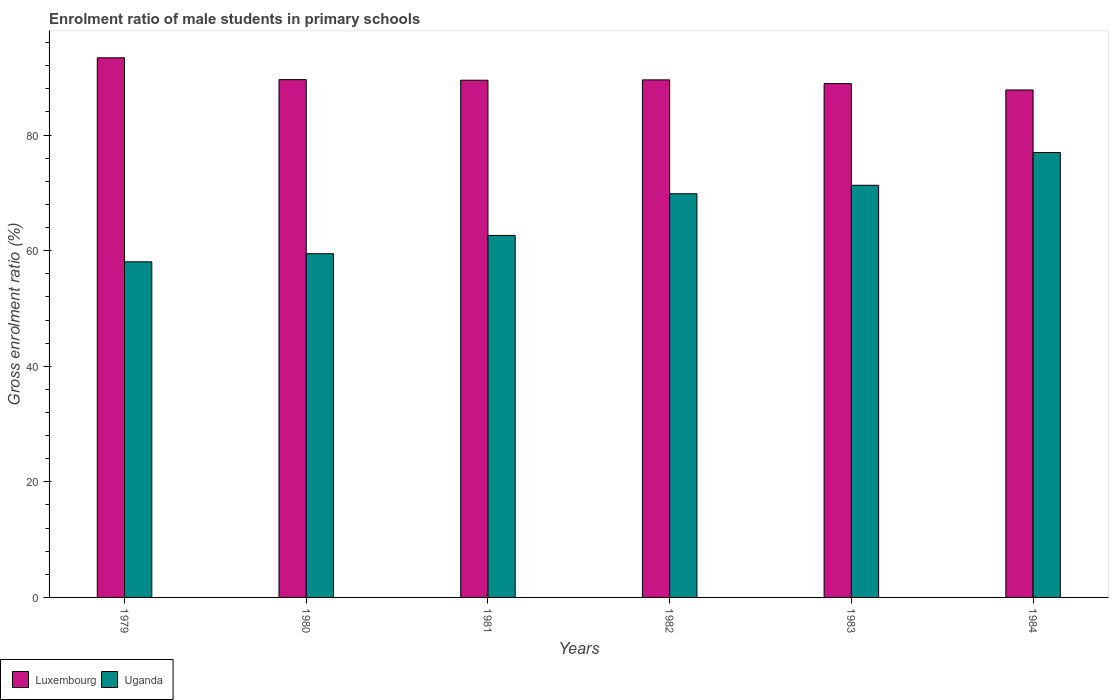How many different coloured bars are there?
Provide a short and direct response. 2. Are the number of bars per tick equal to the number of legend labels?
Offer a very short reply. Yes. How many bars are there on the 6th tick from the right?
Keep it short and to the point. 2. What is the enrolment ratio of male students in primary schools in Uganda in 1980?
Give a very brief answer. 59.48. Across all years, what is the maximum enrolment ratio of male students in primary schools in Luxembourg?
Ensure brevity in your answer.  93.38. Across all years, what is the minimum enrolment ratio of male students in primary schools in Uganda?
Your answer should be very brief. 58.07. In which year was the enrolment ratio of male students in primary schools in Uganda minimum?
Make the answer very short. 1979. What is the total enrolment ratio of male students in primary schools in Uganda in the graph?
Make the answer very short. 398.34. What is the difference between the enrolment ratio of male students in primary schools in Uganda in 1982 and that in 1983?
Ensure brevity in your answer.  -1.47. What is the difference between the enrolment ratio of male students in primary schools in Luxembourg in 1982 and the enrolment ratio of male students in primary schools in Uganda in 1984?
Provide a short and direct response. 12.58. What is the average enrolment ratio of male students in primary schools in Luxembourg per year?
Provide a short and direct response. 89.79. In the year 1980, what is the difference between the enrolment ratio of male students in primary schools in Luxembourg and enrolment ratio of male students in primary schools in Uganda?
Provide a short and direct response. 30.12. What is the ratio of the enrolment ratio of male students in primary schools in Luxembourg in 1980 to that in 1981?
Give a very brief answer. 1. What is the difference between the highest and the second highest enrolment ratio of male students in primary schools in Uganda?
Give a very brief answer. 5.66. What is the difference between the highest and the lowest enrolment ratio of male students in primary schools in Uganda?
Offer a terse response. 18.91. What does the 1st bar from the left in 1981 represents?
Make the answer very short. Luxembourg. What does the 1st bar from the right in 1981 represents?
Make the answer very short. Uganda. Are all the bars in the graph horizontal?
Ensure brevity in your answer.  No. Does the graph contain any zero values?
Ensure brevity in your answer.  No. Where does the legend appear in the graph?
Give a very brief answer. Bottom left. How are the legend labels stacked?
Offer a terse response. Horizontal. What is the title of the graph?
Provide a succinct answer. Enrolment ratio of male students in primary schools. Does "Angola" appear as one of the legend labels in the graph?
Provide a short and direct response. No. What is the Gross enrolment ratio (%) of Luxembourg in 1979?
Make the answer very short. 93.38. What is the Gross enrolment ratio (%) of Uganda in 1979?
Offer a terse response. 58.07. What is the Gross enrolment ratio (%) in Luxembourg in 1980?
Offer a terse response. 89.6. What is the Gross enrolment ratio (%) in Uganda in 1980?
Provide a succinct answer. 59.48. What is the Gross enrolment ratio (%) of Luxembourg in 1981?
Give a very brief answer. 89.5. What is the Gross enrolment ratio (%) of Uganda in 1981?
Offer a terse response. 62.64. What is the Gross enrolment ratio (%) of Luxembourg in 1982?
Provide a short and direct response. 89.56. What is the Gross enrolment ratio (%) of Uganda in 1982?
Make the answer very short. 69.85. What is the Gross enrolment ratio (%) in Luxembourg in 1983?
Make the answer very short. 88.91. What is the Gross enrolment ratio (%) of Uganda in 1983?
Provide a short and direct response. 71.32. What is the Gross enrolment ratio (%) in Luxembourg in 1984?
Provide a succinct answer. 87.81. What is the Gross enrolment ratio (%) of Uganda in 1984?
Provide a succinct answer. 76.98. Across all years, what is the maximum Gross enrolment ratio (%) in Luxembourg?
Your answer should be very brief. 93.38. Across all years, what is the maximum Gross enrolment ratio (%) of Uganda?
Provide a short and direct response. 76.98. Across all years, what is the minimum Gross enrolment ratio (%) of Luxembourg?
Provide a short and direct response. 87.81. Across all years, what is the minimum Gross enrolment ratio (%) of Uganda?
Your answer should be compact. 58.07. What is the total Gross enrolment ratio (%) in Luxembourg in the graph?
Give a very brief answer. 538.75. What is the total Gross enrolment ratio (%) in Uganda in the graph?
Offer a very short reply. 398.34. What is the difference between the Gross enrolment ratio (%) in Luxembourg in 1979 and that in 1980?
Offer a very short reply. 3.78. What is the difference between the Gross enrolment ratio (%) of Uganda in 1979 and that in 1980?
Offer a terse response. -1.4. What is the difference between the Gross enrolment ratio (%) of Luxembourg in 1979 and that in 1981?
Give a very brief answer. 3.88. What is the difference between the Gross enrolment ratio (%) of Uganda in 1979 and that in 1981?
Make the answer very short. -4.57. What is the difference between the Gross enrolment ratio (%) of Luxembourg in 1979 and that in 1982?
Your answer should be very brief. 3.82. What is the difference between the Gross enrolment ratio (%) of Uganda in 1979 and that in 1982?
Your answer should be very brief. -11.78. What is the difference between the Gross enrolment ratio (%) of Luxembourg in 1979 and that in 1983?
Give a very brief answer. 4.46. What is the difference between the Gross enrolment ratio (%) of Uganda in 1979 and that in 1983?
Your answer should be compact. -13.25. What is the difference between the Gross enrolment ratio (%) of Luxembourg in 1979 and that in 1984?
Your answer should be compact. 5.56. What is the difference between the Gross enrolment ratio (%) of Uganda in 1979 and that in 1984?
Your answer should be very brief. -18.91. What is the difference between the Gross enrolment ratio (%) in Luxembourg in 1980 and that in 1981?
Make the answer very short. 0.1. What is the difference between the Gross enrolment ratio (%) of Uganda in 1980 and that in 1981?
Make the answer very short. -3.16. What is the difference between the Gross enrolment ratio (%) of Luxembourg in 1980 and that in 1982?
Your response must be concise. 0.04. What is the difference between the Gross enrolment ratio (%) of Uganda in 1980 and that in 1982?
Your response must be concise. -10.38. What is the difference between the Gross enrolment ratio (%) of Luxembourg in 1980 and that in 1983?
Make the answer very short. 0.69. What is the difference between the Gross enrolment ratio (%) in Uganda in 1980 and that in 1983?
Keep it short and to the point. -11.84. What is the difference between the Gross enrolment ratio (%) of Luxembourg in 1980 and that in 1984?
Provide a short and direct response. 1.79. What is the difference between the Gross enrolment ratio (%) of Uganda in 1980 and that in 1984?
Your response must be concise. -17.51. What is the difference between the Gross enrolment ratio (%) of Luxembourg in 1981 and that in 1982?
Your response must be concise. -0.06. What is the difference between the Gross enrolment ratio (%) of Uganda in 1981 and that in 1982?
Ensure brevity in your answer.  -7.21. What is the difference between the Gross enrolment ratio (%) in Luxembourg in 1981 and that in 1983?
Your response must be concise. 0.59. What is the difference between the Gross enrolment ratio (%) of Uganda in 1981 and that in 1983?
Offer a terse response. -8.68. What is the difference between the Gross enrolment ratio (%) in Luxembourg in 1981 and that in 1984?
Provide a short and direct response. 1.69. What is the difference between the Gross enrolment ratio (%) of Uganda in 1981 and that in 1984?
Your answer should be compact. -14.34. What is the difference between the Gross enrolment ratio (%) of Luxembourg in 1982 and that in 1983?
Provide a succinct answer. 0.65. What is the difference between the Gross enrolment ratio (%) in Uganda in 1982 and that in 1983?
Offer a terse response. -1.47. What is the difference between the Gross enrolment ratio (%) in Luxembourg in 1982 and that in 1984?
Give a very brief answer. 1.75. What is the difference between the Gross enrolment ratio (%) of Uganda in 1982 and that in 1984?
Your response must be concise. -7.13. What is the difference between the Gross enrolment ratio (%) of Luxembourg in 1983 and that in 1984?
Keep it short and to the point. 1.1. What is the difference between the Gross enrolment ratio (%) of Uganda in 1983 and that in 1984?
Your answer should be compact. -5.66. What is the difference between the Gross enrolment ratio (%) in Luxembourg in 1979 and the Gross enrolment ratio (%) in Uganda in 1980?
Give a very brief answer. 33.9. What is the difference between the Gross enrolment ratio (%) of Luxembourg in 1979 and the Gross enrolment ratio (%) of Uganda in 1981?
Keep it short and to the point. 30.74. What is the difference between the Gross enrolment ratio (%) of Luxembourg in 1979 and the Gross enrolment ratio (%) of Uganda in 1982?
Offer a very short reply. 23.52. What is the difference between the Gross enrolment ratio (%) in Luxembourg in 1979 and the Gross enrolment ratio (%) in Uganda in 1983?
Keep it short and to the point. 22.06. What is the difference between the Gross enrolment ratio (%) in Luxembourg in 1979 and the Gross enrolment ratio (%) in Uganda in 1984?
Your response must be concise. 16.39. What is the difference between the Gross enrolment ratio (%) in Luxembourg in 1980 and the Gross enrolment ratio (%) in Uganda in 1981?
Offer a very short reply. 26.96. What is the difference between the Gross enrolment ratio (%) in Luxembourg in 1980 and the Gross enrolment ratio (%) in Uganda in 1982?
Make the answer very short. 19.75. What is the difference between the Gross enrolment ratio (%) in Luxembourg in 1980 and the Gross enrolment ratio (%) in Uganda in 1983?
Your response must be concise. 18.28. What is the difference between the Gross enrolment ratio (%) of Luxembourg in 1980 and the Gross enrolment ratio (%) of Uganda in 1984?
Make the answer very short. 12.62. What is the difference between the Gross enrolment ratio (%) of Luxembourg in 1981 and the Gross enrolment ratio (%) of Uganda in 1982?
Your response must be concise. 19.65. What is the difference between the Gross enrolment ratio (%) of Luxembourg in 1981 and the Gross enrolment ratio (%) of Uganda in 1983?
Provide a short and direct response. 18.18. What is the difference between the Gross enrolment ratio (%) in Luxembourg in 1981 and the Gross enrolment ratio (%) in Uganda in 1984?
Make the answer very short. 12.52. What is the difference between the Gross enrolment ratio (%) in Luxembourg in 1982 and the Gross enrolment ratio (%) in Uganda in 1983?
Offer a very short reply. 18.24. What is the difference between the Gross enrolment ratio (%) in Luxembourg in 1982 and the Gross enrolment ratio (%) in Uganda in 1984?
Offer a very short reply. 12.58. What is the difference between the Gross enrolment ratio (%) of Luxembourg in 1983 and the Gross enrolment ratio (%) of Uganda in 1984?
Keep it short and to the point. 11.93. What is the average Gross enrolment ratio (%) of Luxembourg per year?
Provide a short and direct response. 89.79. What is the average Gross enrolment ratio (%) of Uganda per year?
Offer a very short reply. 66.39. In the year 1979, what is the difference between the Gross enrolment ratio (%) in Luxembourg and Gross enrolment ratio (%) in Uganda?
Keep it short and to the point. 35.3. In the year 1980, what is the difference between the Gross enrolment ratio (%) in Luxembourg and Gross enrolment ratio (%) in Uganda?
Provide a succinct answer. 30.12. In the year 1981, what is the difference between the Gross enrolment ratio (%) of Luxembourg and Gross enrolment ratio (%) of Uganda?
Ensure brevity in your answer.  26.86. In the year 1982, what is the difference between the Gross enrolment ratio (%) of Luxembourg and Gross enrolment ratio (%) of Uganda?
Provide a succinct answer. 19.71. In the year 1983, what is the difference between the Gross enrolment ratio (%) of Luxembourg and Gross enrolment ratio (%) of Uganda?
Your answer should be very brief. 17.59. In the year 1984, what is the difference between the Gross enrolment ratio (%) of Luxembourg and Gross enrolment ratio (%) of Uganda?
Your answer should be compact. 10.83. What is the ratio of the Gross enrolment ratio (%) in Luxembourg in 1979 to that in 1980?
Ensure brevity in your answer.  1.04. What is the ratio of the Gross enrolment ratio (%) of Uganda in 1979 to that in 1980?
Your response must be concise. 0.98. What is the ratio of the Gross enrolment ratio (%) in Luxembourg in 1979 to that in 1981?
Offer a very short reply. 1.04. What is the ratio of the Gross enrolment ratio (%) in Uganda in 1979 to that in 1981?
Give a very brief answer. 0.93. What is the ratio of the Gross enrolment ratio (%) of Luxembourg in 1979 to that in 1982?
Provide a short and direct response. 1.04. What is the ratio of the Gross enrolment ratio (%) of Uganda in 1979 to that in 1982?
Ensure brevity in your answer.  0.83. What is the ratio of the Gross enrolment ratio (%) in Luxembourg in 1979 to that in 1983?
Ensure brevity in your answer.  1.05. What is the ratio of the Gross enrolment ratio (%) in Uganda in 1979 to that in 1983?
Your response must be concise. 0.81. What is the ratio of the Gross enrolment ratio (%) in Luxembourg in 1979 to that in 1984?
Offer a very short reply. 1.06. What is the ratio of the Gross enrolment ratio (%) of Uganda in 1979 to that in 1984?
Provide a short and direct response. 0.75. What is the ratio of the Gross enrolment ratio (%) of Uganda in 1980 to that in 1981?
Keep it short and to the point. 0.95. What is the ratio of the Gross enrolment ratio (%) in Uganda in 1980 to that in 1982?
Make the answer very short. 0.85. What is the ratio of the Gross enrolment ratio (%) in Luxembourg in 1980 to that in 1983?
Provide a succinct answer. 1.01. What is the ratio of the Gross enrolment ratio (%) of Uganda in 1980 to that in 1983?
Keep it short and to the point. 0.83. What is the ratio of the Gross enrolment ratio (%) of Luxembourg in 1980 to that in 1984?
Ensure brevity in your answer.  1.02. What is the ratio of the Gross enrolment ratio (%) in Uganda in 1980 to that in 1984?
Give a very brief answer. 0.77. What is the ratio of the Gross enrolment ratio (%) in Uganda in 1981 to that in 1982?
Ensure brevity in your answer.  0.9. What is the ratio of the Gross enrolment ratio (%) in Luxembourg in 1981 to that in 1983?
Offer a very short reply. 1.01. What is the ratio of the Gross enrolment ratio (%) of Uganda in 1981 to that in 1983?
Your response must be concise. 0.88. What is the ratio of the Gross enrolment ratio (%) in Luxembourg in 1981 to that in 1984?
Your response must be concise. 1.02. What is the ratio of the Gross enrolment ratio (%) in Uganda in 1981 to that in 1984?
Offer a very short reply. 0.81. What is the ratio of the Gross enrolment ratio (%) in Luxembourg in 1982 to that in 1983?
Your answer should be very brief. 1.01. What is the ratio of the Gross enrolment ratio (%) in Uganda in 1982 to that in 1983?
Your answer should be compact. 0.98. What is the ratio of the Gross enrolment ratio (%) of Luxembourg in 1982 to that in 1984?
Provide a succinct answer. 1.02. What is the ratio of the Gross enrolment ratio (%) in Uganda in 1982 to that in 1984?
Offer a terse response. 0.91. What is the ratio of the Gross enrolment ratio (%) in Luxembourg in 1983 to that in 1984?
Keep it short and to the point. 1.01. What is the ratio of the Gross enrolment ratio (%) of Uganda in 1983 to that in 1984?
Make the answer very short. 0.93. What is the difference between the highest and the second highest Gross enrolment ratio (%) of Luxembourg?
Offer a terse response. 3.78. What is the difference between the highest and the second highest Gross enrolment ratio (%) in Uganda?
Give a very brief answer. 5.66. What is the difference between the highest and the lowest Gross enrolment ratio (%) of Luxembourg?
Offer a very short reply. 5.56. What is the difference between the highest and the lowest Gross enrolment ratio (%) in Uganda?
Offer a terse response. 18.91. 